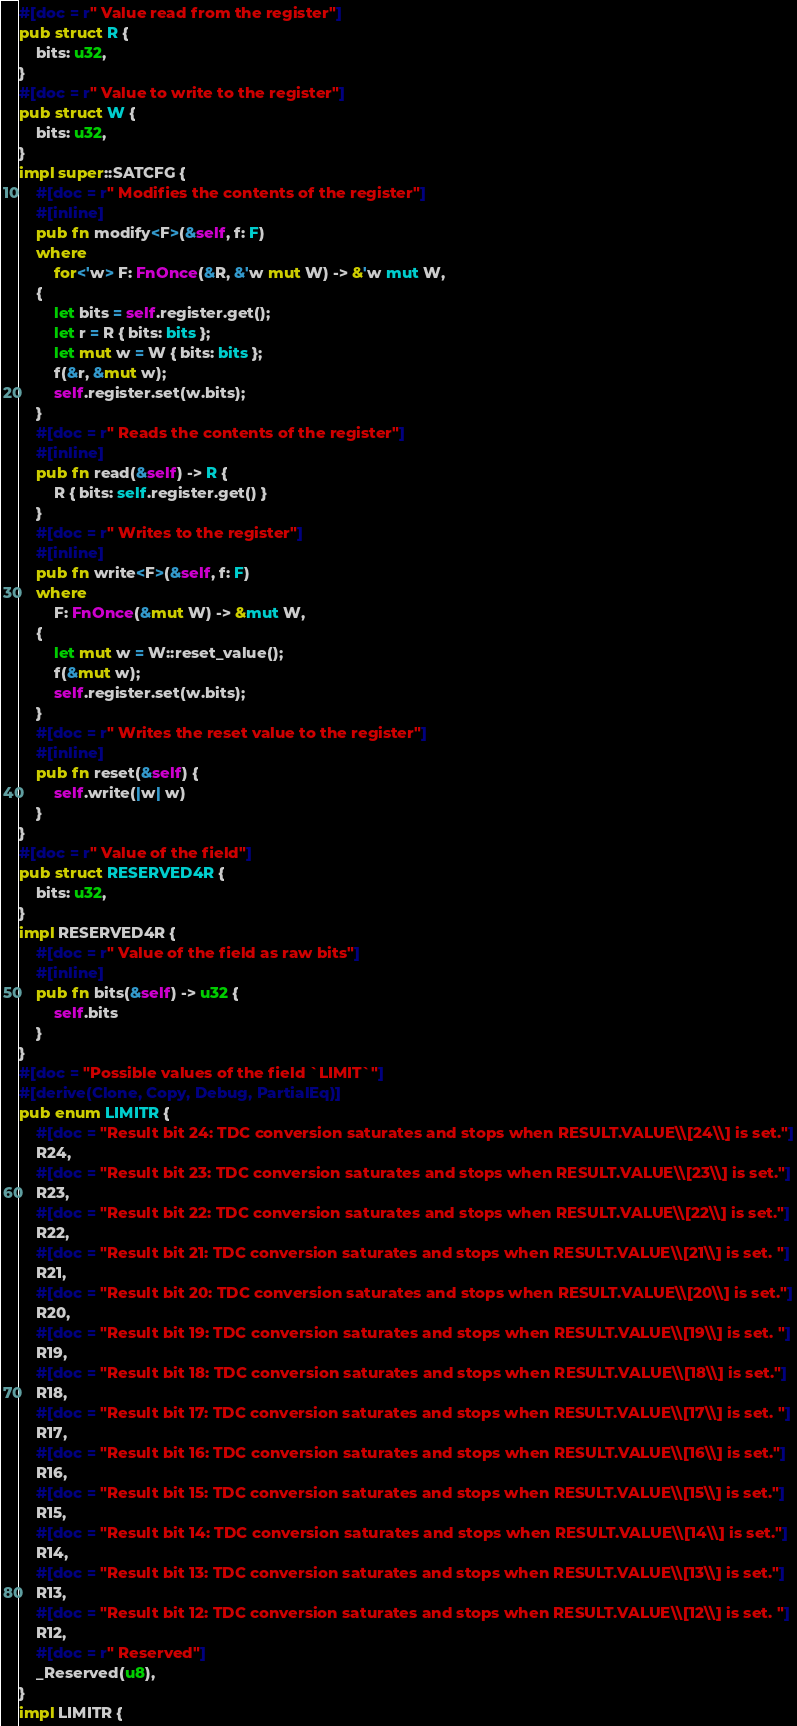<code> <loc_0><loc_0><loc_500><loc_500><_Rust_>#[doc = r" Value read from the register"]
pub struct R {
    bits: u32,
}
#[doc = r" Value to write to the register"]
pub struct W {
    bits: u32,
}
impl super::SATCFG {
    #[doc = r" Modifies the contents of the register"]
    #[inline]
    pub fn modify<F>(&self, f: F)
    where
        for<'w> F: FnOnce(&R, &'w mut W) -> &'w mut W,
    {
        let bits = self.register.get();
        let r = R { bits: bits };
        let mut w = W { bits: bits };
        f(&r, &mut w);
        self.register.set(w.bits);
    }
    #[doc = r" Reads the contents of the register"]
    #[inline]
    pub fn read(&self) -> R {
        R { bits: self.register.get() }
    }
    #[doc = r" Writes to the register"]
    #[inline]
    pub fn write<F>(&self, f: F)
    where
        F: FnOnce(&mut W) -> &mut W,
    {
        let mut w = W::reset_value();
        f(&mut w);
        self.register.set(w.bits);
    }
    #[doc = r" Writes the reset value to the register"]
    #[inline]
    pub fn reset(&self) {
        self.write(|w| w)
    }
}
#[doc = r" Value of the field"]
pub struct RESERVED4R {
    bits: u32,
}
impl RESERVED4R {
    #[doc = r" Value of the field as raw bits"]
    #[inline]
    pub fn bits(&self) -> u32 {
        self.bits
    }
}
#[doc = "Possible values of the field `LIMIT`"]
#[derive(Clone, Copy, Debug, PartialEq)]
pub enum LIMITR {
    #[doc = "Result bit 24: TDC conversion saturates and stops when RESULT.VALUE\\[24\\] is set."]
    R24,
    #[doc = "Result bit 23: TDC conversion saturates and stops when RESULT.VALUE\\[23\\] is set."]
    R23,
    #[doc = "Result bit 22: TDC conversion saturates and stops when RESULT.VALUE\\[22\\] is set."]
    R22,
    #[doc = "Result bit 21: TDC conversion saturates and stops when RESULT.VALUE\\[21\\] is set. "]
    R21,
    #[doc = "Result bit 20: TDC conversion saturates and stops when RESULT.VALUE\\[20\\] is set."]
    R20,
    #[doc = "Result bit 19: TDC conversion saturates and stops when RESULT.VALUE\\[19\\] is set. "]
    R19,
    #[doc = "Result bit 18: TDC conversion saturates and stops when RESULT.VALUE\\[18\\] is set."]
    R18,
    #[doc = "Result bit 17: TDC conversion saturates and stops when RESULT.VALUE\\[17\\] is set. "]
    R17,
    #[doc = "Result bit 16: TDC conversion saturates and stops when RESULT.VALUE\\[16\\] is set."]
    R16,
    #[doc = "Result bit 15: TDC conversion saturates and stops when RESULT.VALUE\\[15\\] is set."]
    R15,
    #[doc = "Result bit 14: TDC conversion saturates and stops when RESULT.VALUE\\[14\\] is set."]
    R14,
    #[doc = "Result bit 13: TDC conversion saturates and stops when RESULT.VALUE\\[13\\] is set."]
    R13,
    #[doc = "Result bit 12: TDC conversion saturates and stops when RESULT.VALUE\\[12\\] is set. "]
    R12,
    #[doc = r" Reserved"]
    _Reserved(u8),
}
impl LIMITR {</code> 